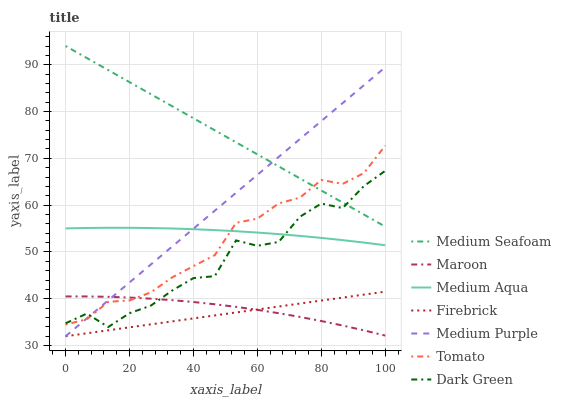Does Firebrick have the minimum area under the curve?
Answer yes or no. Yes. Does Medium Seafoam have the maximum area under the curve?
Answer yes or no. Yes. Does Maroon have the minimum area under the curve?
Answer yes or no. No. Does Maroon have the maximum area under the curve?
Answer yes or no. No. Is Firebrick the smoothest?
Answer yes or no. Yes. Is Dark Green the roughest?
Answer yes or no. Yes. Is Maroon the smoothest?
Answer yes or no. No. Is Maroon the roughest?
Answer yes or no. No. Does Firebrick have the lowest value?
Answer yes or no. Yes. Does Maroon have the lowest value?
Answer yes or no. No. Does Medium Seafoam have the highest value?
Answer yes or no. Yes. Does Firebrick have the highest value?
Answer yes or no. No. Is Medium Aqua less than Medium Seafoam?
Answer yes or no. Yes. Is Medium Seafoam greater than Firebrick?
Answer yes or no. Yes. Does Tomato intersect Maroon?
Answer yes or no. Yes. Is Tomato less than Maroon?
Answer yes or no. No. Is Tomato greater than Maroon?
Answer yes or no. No. Does Medium Aqua intersect Medium Seafoam?
Answer yes or no. No. 